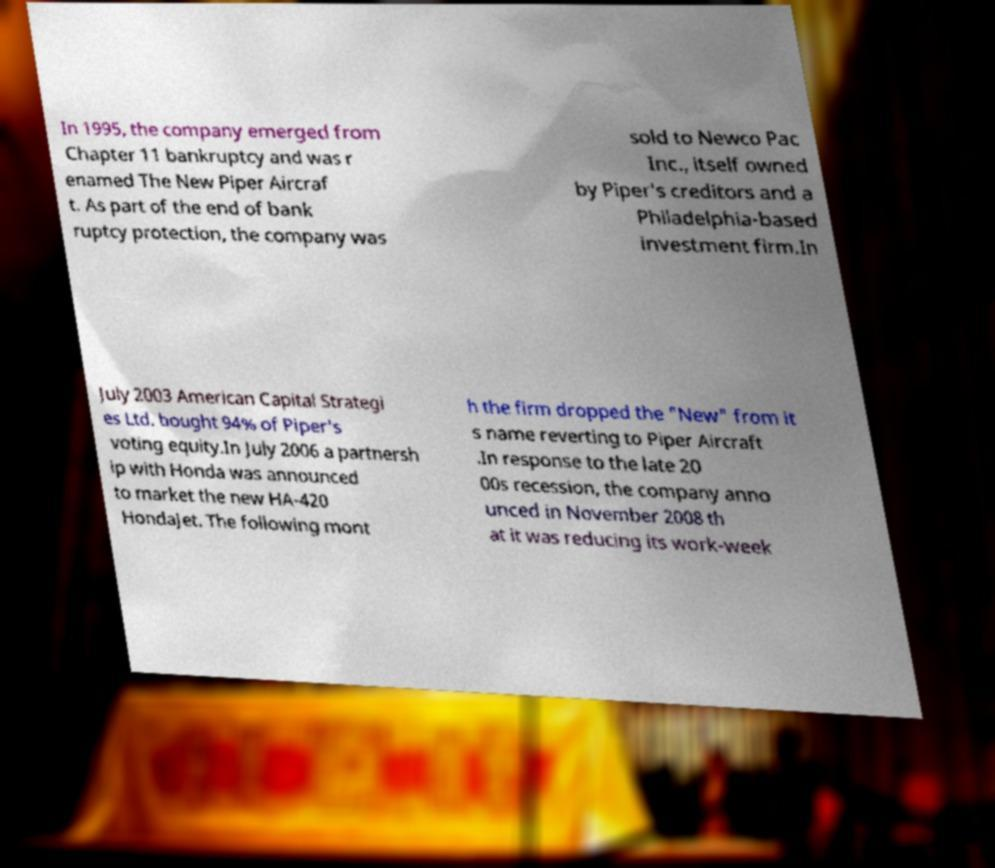Please read and relay the text visible in this image. What does it say? In 1995, the company emerged from Chapter 11 bankruptcy and was r enamed The New Piper Aircraf t. As part of the end of bank ruptcy protection, the company was sold to Newco Pac Inc., itself owned by Piper's creditors and a Philadelphia-based investment firm.In July 2003 American Capital Strategi es Ltd. bought 94% of Piper's voting equity.In July 2006 a partnersh ip with Honda was announced to market the new HA-420 HondaJet. The following mont h the firm dropped the "New" from it s name reverting to Piper Aircraft .In response to the late 20 00s recession, the company anno unced in November 2008 th at it was reducing its work-week 